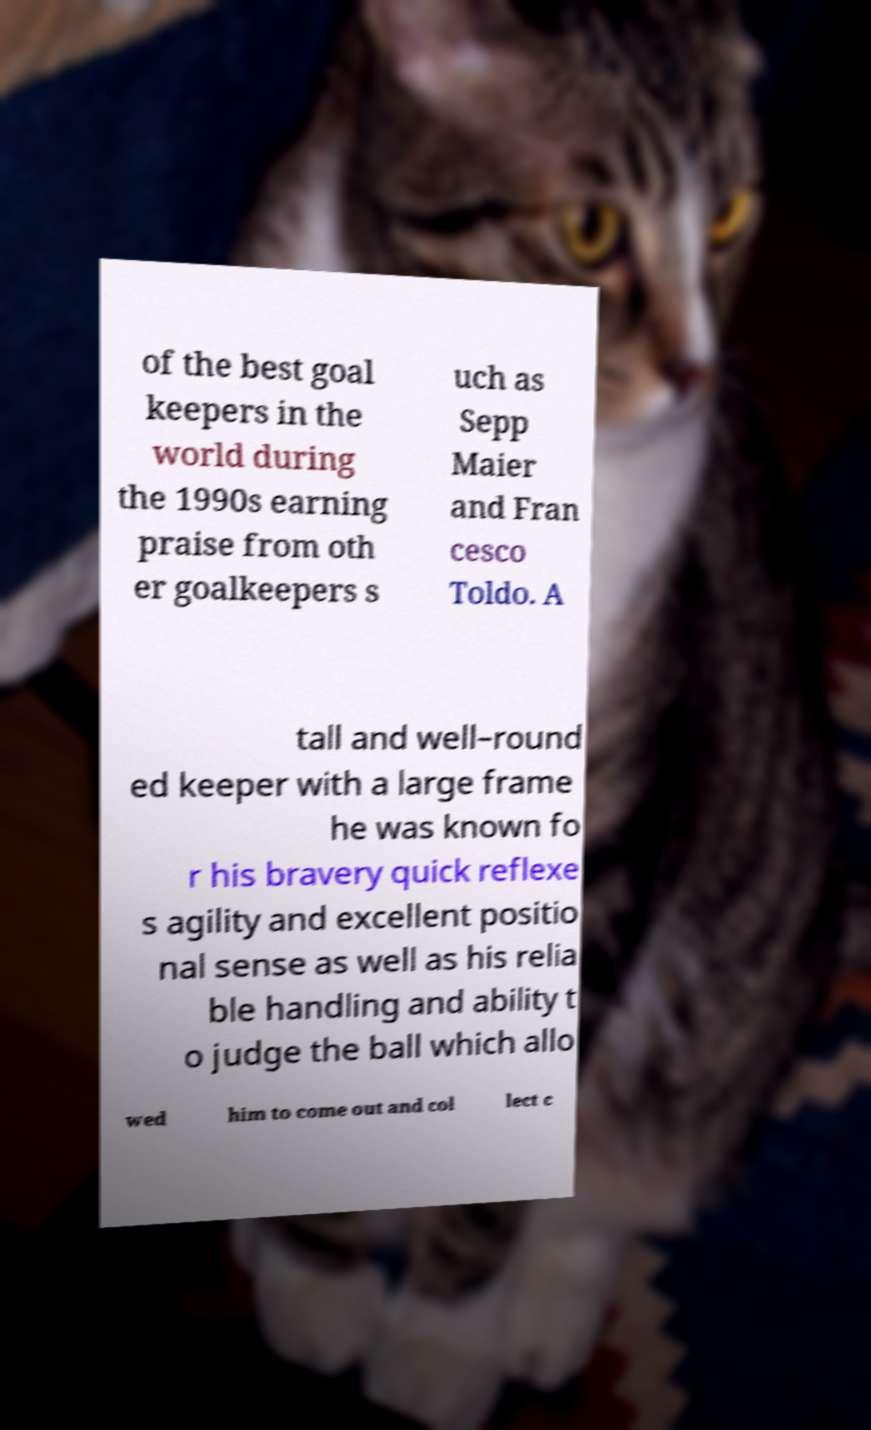For documentation purposes, I need the text within this image transcribed. Could you provide that? of the best goal keepers in the world during the 1990s earning praise from oth er goalkeepers s uch as Sepp Maier and Fran cesco Toldo. A tall and well–round ed keeper with a large frame he was known fo r his bravery quick reflexe s agility and excellent positio nal sense as well as his relia ble handling and ability t o judge the ball which allo wed him to come out and col lect c 